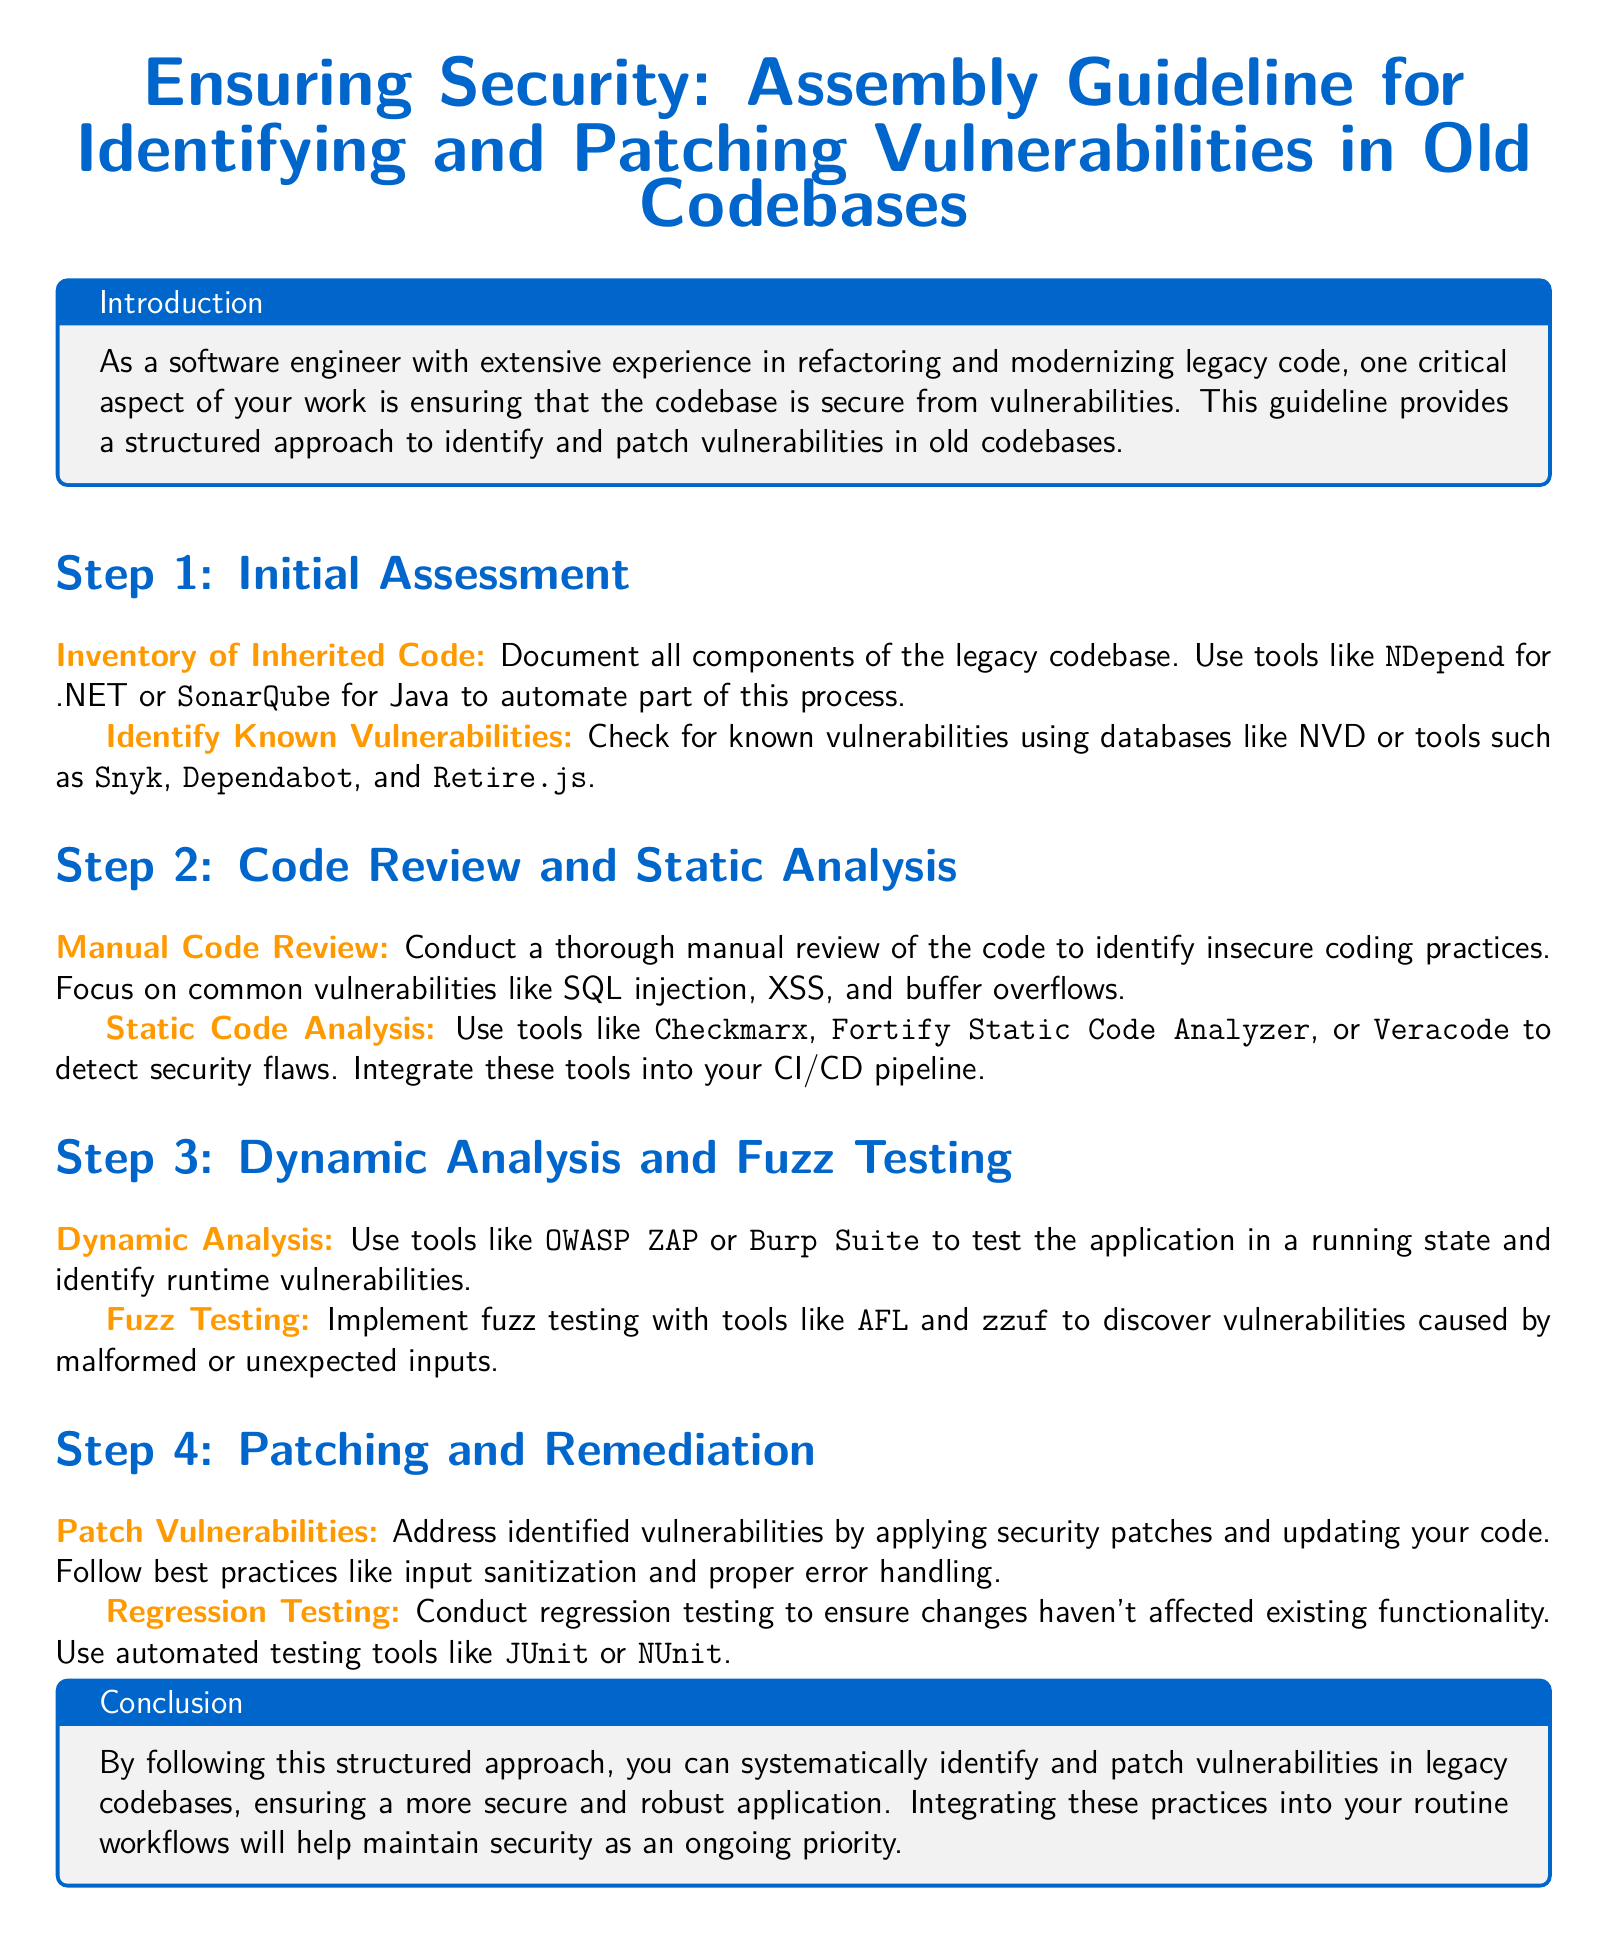What is the title of the document? The title is presented at the top of the document and refers to the guidelines for security in legacy code.
Answer: Ensuring Security: Assembly Guideline for Identifying and Patching Vulnerabilities in Old Codebases What is the first step in the guideline? The steps are listed in sequence, and the first step is described in the document.
Answer: Initial Assessment Which tool is recommended for static code analysis? The document suggests using specific tools for different analysis types, including static code analysis.
Answer: Checkmarx What two common vulnerabilities are highlighted for manual review? The document specifies common vulnerabilities to focus on during manual code reviews.
Answer: SQL injection, XSS What is the purpose of regression testing? The role of regression testing is described, linking it to changes made in the codebase.
Answer: Ensure changes haven't affected existing functionality How many steps are outlined in this guideline? The document lists distinct steps for the process, summarizing the overall approach.
Answer: Four What color is used for section headers in the document? The document defines colors used for different elements, including section headers.
Answer: Main color What is a tool mentioned for fuzz testing? The document provides examples of tools to utilize for testing vulnerabilities, including fuzz testing.
Answer: AFL 